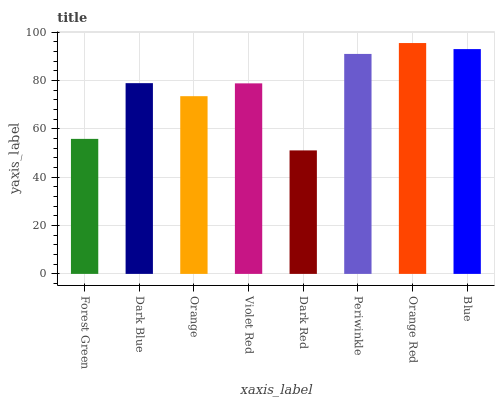Is Dark Red the minimum?
Answer yes or no. Yes. Is Orange Red the maximum?
Answer yes or no. Yes. Is Dark Blue the minimum?
Answer yes or no. No. Is Dark Blue the maximum?
Answer yes or no. No. Is Dark Blue greater than Forest Green?
Answer yes or no. Yes. Is Forest Green less than Dark Blue?
Answer yes or no. Yes. Is Forest Green greater than Dark Blue?
Answer yes or no. No. Is Dark Blue less than Forest Green?
Answer yes or no. No. Is Dark Blue the high median?
Answer yes or no. Yes. Is Violet Red the low median?
Answer yes or no. Yes. Is Blue the high median?
Answer yes or no. No. Is Orange the low median?
Answer yes or no. No. 